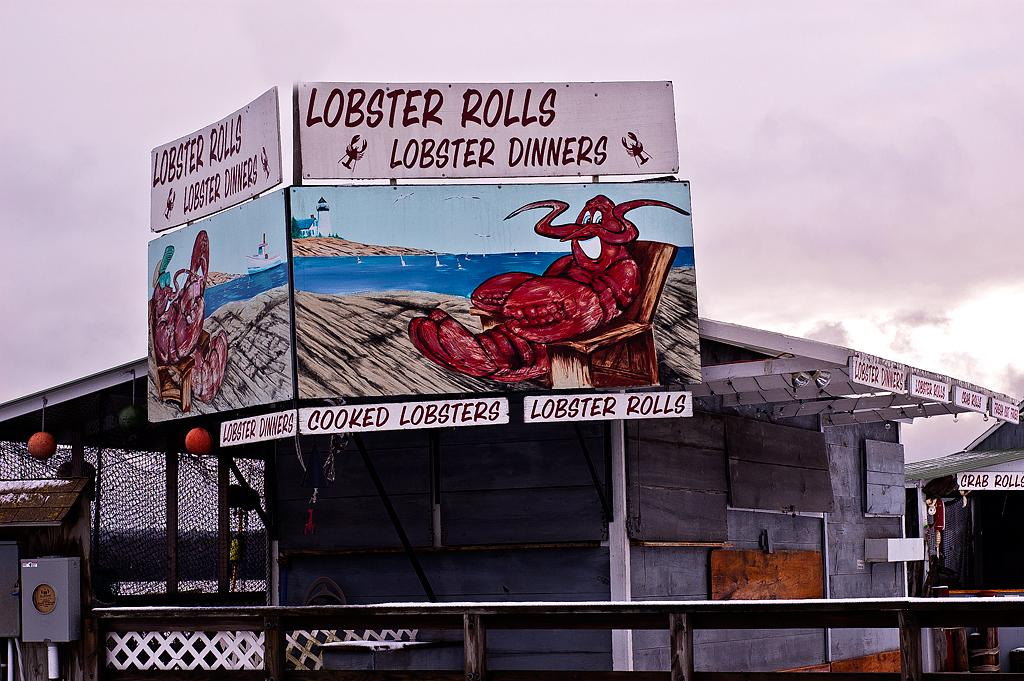<image>
Render a clear and concise summary of the photo. A grey American shack-style building has two identical signs  with a large red cartoon lobster, indicating they sell Lobster rolls and Lobster Dinners. 